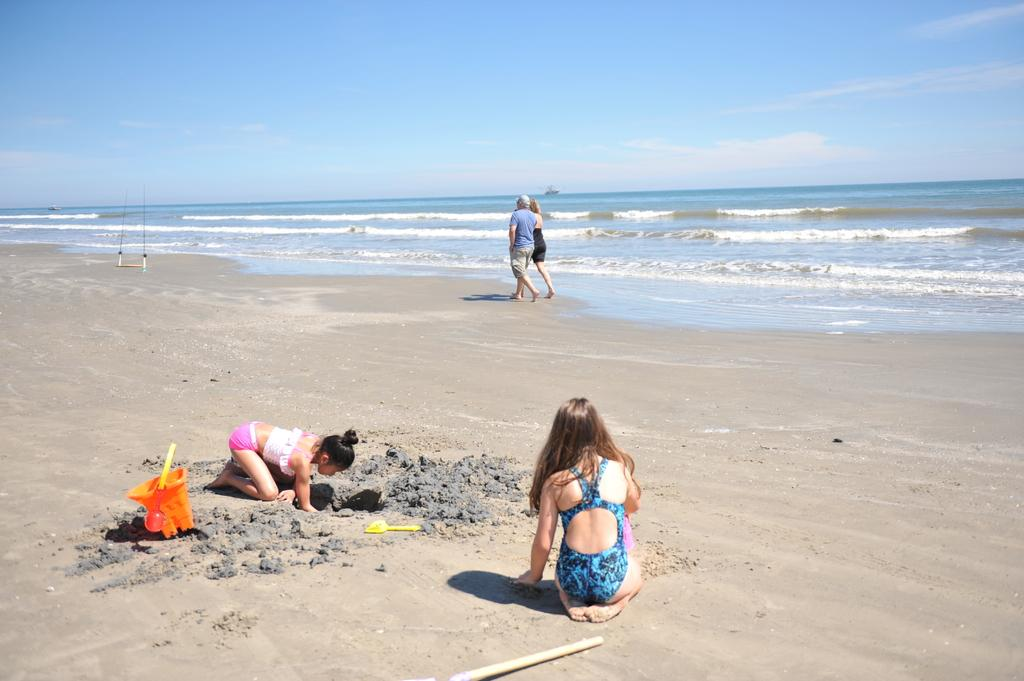How many people are in the image? There are four persons in the image. Where are the persons located? The persons are on a beach. What can be seen in the background of the image? The background of the image includes the ocean. What is the color of the sky in the image? The sky is blue in the image. What type of surface is present on the beach? The beach has sand. What type of egg is visible in the image? There is no egg present in the image; it features four persons on a beach with a blue sky and ocean in the background. 